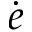<formula> <loc_0><loc_0><loc_500><loc_500>\dot { e }</formula> 